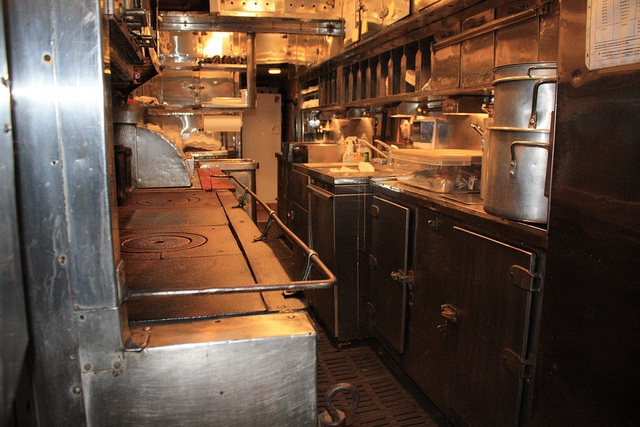Describe the objects in this image and their specific colors. I can see oven in gray, black, maroon, and orange tones, refrigerator in gray, brown, red, and maroon tones, sink in gray, tan, orange, brown, and khaki tones, and spoon in gray, orange, brown, maroon, and salmon tones in this image. 